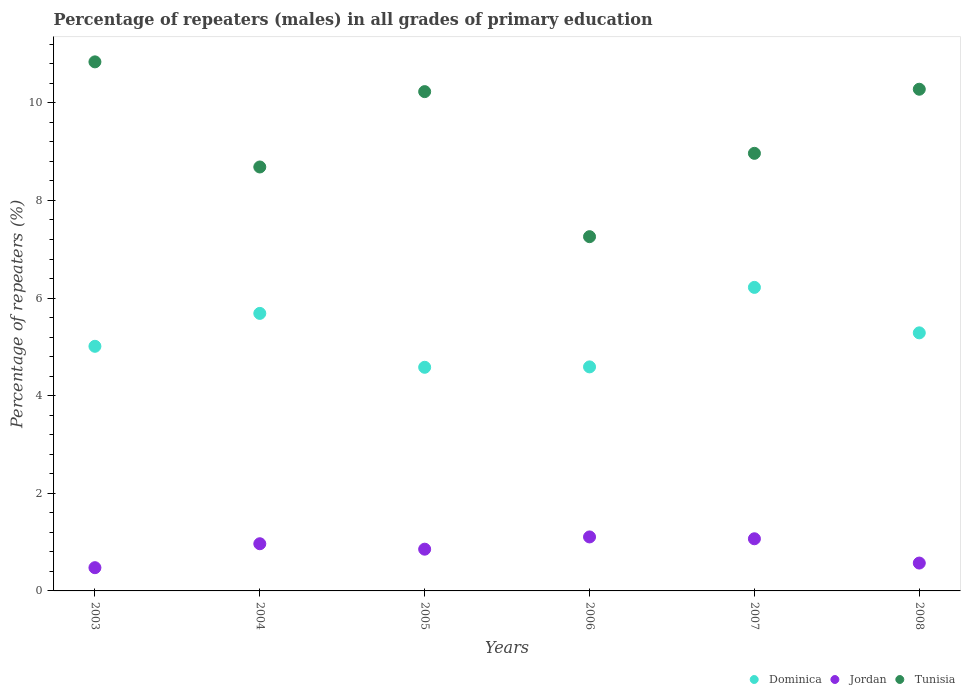What is the percentage of repeaters (males) in Tunisia in 2007?
Offer a terse response. 8.97. Across all years, what is the maximum percentage of repeaters (males) in Jordan?
Ensure brevity in your answer.  1.11. Across all years, what is the minimum percentage of repeaters (males) in Tunisia?
Offer a very short reply. 7.26. In which year was the percentage of repeaters (males) in Jordan maximum?
Your answer should be very brief. 2006. What is the total percentage of repeaters (males) in Jordan in the graph?
Provide a short and direct response. 5.04. What is the difference between the percentage of repeaters (males) in Jordan in 2004 and that in 2007?
Your response must be concise. -0.1. What is the difference between the percentage of repeaters (males) in Jordan in 2004 and the percentage of repeaters (males) in Tunisia in 2008?
Make the answer very short. -9.31. What is the average percentage of repeaters (males) in Dominica per year?
Your answer should be compact. 5.23. In the year 2006, what is the difference between the percentage of repeaters (males) in Dominica and percentage of repeaters (males) in Jordan?
Your response must be concise. 3.48. What is the ratio of the percentage of repeaters (males) in Tunisia in 2007 to that in 2008?
Keep it short and to the point. 0.87. Is the percentage of repeaters (males) in Tunisia in 2004 less than that in 2006?
Ensure brevity in your answer.  No. What is the difference between the highest and the second highest percentage of repeaters (males) in Tunisia?
Your response must be concise. 0.56. What is the difference between the highest and the lowest percentage of repeaters (males) in Dominica?
Keep it short and to the point. 1.64. Is it the case that in every year, the sum of the percentage of repeaters (males) in Tunisia and percentage of repeaters (males) in Dominica  is greater than the percentage of repeaters (males) in Jordan?
Provide a succinct answer. Yes. Is the percentage of repeaters (males) in Dominica strictly less than the percentage of repeaters (males) in Tunisia over the years?
Make the answer very short. Yes. How many years are there in the graph?
Your answer should be compact. 6. Are the values on the major ticks of Y-axis written in scientific E-notation?
Your response must be concise. No. Does the graph contain any zero values?
Keep it short and to the point. No. Where does the legend appear in the graph?
Make the answer very short. Bottom right. How many legend labels are there?
Ensure brevity in your answer.  3. What is the title of the graph?
Provide a succinct answer. Percentage of repeaters (males) in all grades of primary education. Does "Indonesia" appear as one of the legend labels in the graph?
Offer a terse response. No. What is the label or title of the X-axis?
Make the answer very short. Years. What is the label or title of the Y-axis?
Keep it short and to the point. Percentage of repeaters (%). What is the Percentage of repeaters (%) in Dominica in 2003?
Keep it short and to the point. 5.01. What is the Percentage of repeaters (%) of Jordan in 2003?
Offer a terse response. 0.48. What is the Percentage of repeaters (%) in Tunisia in 2003?
Give a very brief answer. 10.84. What is the Percentage of repeaters (%) in Dominica in 2004?
Offer a terse response. 5.69. What is the Percentage of repeaters (%) in Jordan in 2004?
Offer a terse response. 0.97. What is the Percentage of repeaters (%) of Tunisia in 2004?
Your answer should be compact. 8.69. What is the Percentage of repeaters (%) in Dominica in 2005?
Offer a terse response. 4.58. What is the Percentage of repeaters (%) in Jordan in 2005?
Give a very brief answer. 0.86. What is the Percentage of repeaters (%) of Tunisia in 2005?
Your answer should be very brief. 10.23. What is the Percentage of repeaters (%) of Dominica in 2006?
Give a very brief answer. 4.59. What is the Percentage of repeaters (%) of Jordan in 2006?
Give a very brief answer. 1.11. What is the Percentage of repeaters (%) in Tunisia in 2006?
Your answer should be very brief. 7.26. What is the Percentage of repeaters (%) of Dominica in 2007?
Provide a short and direct response. 6.22. What is the Percentage of repeaters (%) of Jordan in 2007?
Provide a succinct answer. 1.07. What is the Percentage of repeaters (%) of Tunisia in 2007?
Offer a very short reply. 8.97. What is the Percentage of repeaters (%) in Dominica in 2008?
Your answer should be compact. 5.29. What is the Percentage of repeaters (%) in Jordan in 2008?
Offer a very short reply. 0.57. What is the Percentage of repeaters (%) in Tunisia in 2008?
Make the answer very short. 10.28. Across all years, what is the maximum Percentage of repeaters (%) in Dominica?
Make the answer very short. 6.22. Across all years, what is the maximum Percentage of repeaters (%) in Jordan?
Provide a short and direct response. 1.11. Across all years, what is the maximum Percentage of repeaters (%) of Tunisia?
Your answer should be very brief. 10.84. Across all years, what is the minimum Percentage of repeaters (%) in Dominica?
Offer a terse response. 4.58. Across all years, what is the minimum Percentage of repeaters (%) of Jordan?
Provide a short and direct response. 0.48. Across all years, what is the minimum Percentage of repeaters (%) of Tunisia?
Ensure brevity in your answer.  7.26. What is the total Percentage of repeaters (%) in Dominica in the graph?
Your answer should be compact. 31.38. What is the total Percentage of repeaters (%) of Jordan in the graph?
Provide a succinct answer. 5.04. What is the total Percentage of repeaters (%) of Tunisia in the graph?
Your answer should be compact. 56.26. What is the difference between the Percentage of repeaters (%) in Dominica in 2003 and that in 2004?
Your answer should be compact. -0.67. What is the difference between the Percentage of repeaters (%) in Jordan in 2003 and that in 2004?
Ensure brevity in your answer.  -0.49. What is the difference between the Percentage of repeaters (%) in Tunisia in 2003 and that in 2004?
Offer a very short reply. 2.15. What is the difference between the Percentage of repeaters (%) in Dominica in 2003 and that in 2005?
Provide a succinct answer. 0.43. What is the difference between the Percentage of repeaters (%) in Jordan in 2003 and that in 2005?
Make the answer very short. -0.38. What is the difference between the Percentage of repeaters (%) of Tunisia in 2003 and that in 2005?
Keep it short and to the point. 0.61. What is the difference between the Percentage of repeaters (%) in Dominica in 2003 and that in 2006?
Provide a short and direct response. 0.42. What is the difference between the Percentage of repeaters (%) of Jordan in 2003 and that in 2006?
Your answer should be very brief. -0.63. What is the difference between the Percentage of repeaters (%) of Tunisia in 2003 and that in 2006?
Offer a very short reply. 3.58. What is the difference between the Percentage of repeaters (%) of Dominica in 2003 and that in 2007?
Offer a terse response. -1.21. What is the difference between the Percentage of repeaters (%) of Jordan in 2003 and that in 2007?
Offer a very short reply. -0.59. What is the difference between the Percentage of repeaters (%) in Tunisia in 2003 and that in 2007?
Keep it short and to the point. 1.87. What is the difference between the Percentage of repeaters (%) in Dominica in 2003 and that in 2008?
Provide a succinct answer. -0.28. What is the difference between the Percentage of repeaters (%) in Jordan in 2003 and that in 2008?
Your response must be concise. -0.09. What is the difference between the Percentage of repeaters (%) of Tunisia in 2003 and that in 2008?
Offer a very short reply. 0.56. What is the difference between the Percentage of repeaters (%) of Dominica in 2004 and that in 2005?
Keep it short and to the point. 1.1. What is the difference between the Percentage of repeaters (%) in Jordan in 2004 and that in 2005?
Your response must be concise. 0.11. What is the difference between the Percentage of repeaters (%) in Tunisia in 2004 and that in 2005?
Give a very brief answer. -1.54. What is the difference between the Percentage of repeaters (%) of Dominica in 2004 and that in 2006?
Ensure brevity in your answer.  1.1. What is the difference between the Percentage of repeaters (%) in Jordan in 2004 and that in 2006?
Ensure brevity in your answer.  -0.14. What is the difference between the Percentage of repeaters (%) in Tunisia in 2004 and that in 2006?
Give a very brief answer. 1.43. What is the difference between the Percentage of repeaters (%) of Dominica in 2004 and that in 2007?
Your answer should be very brief. -0.53. What is the difference between the Percentage of repeaters (%) of Jordan in 2004 and that in 2007?
Your answer should be compact. -0.1. What is the difference between the Percentage of repeaters (%) in Tunisia in 2004 and that in 2007?
Give a very brief answer. -0.28. What is the difference between the Percentage of repeaters (%) in Dominica in 2004 and that in 2008?
Keep it short and to the point. 0.4. What is the difference between the Percentage of repeaters (%) of Jordan in 2004 and that in 2008?
Provide a short and direct response. 0.4. What is the difference between the Percentage of repeaters (%) in Tunisia in 2004 and that in 2008?
Provide a succinct answer. -1.59. What is the difference between the Percentage of repeaters (%) in Dominica in 2005 and that in 2006?
Offer a very short reply. -0.01. What is the difference between the Percentage of repeaters (%) of Jordan in 2005 and that in 2006?
Keep it short and to the point. -0.25. What is the difference between the Percentage of repeaters (%) in Tunisia in 2005 and that in 2006?
Your response must be concise. 2.97. What is the difference between the Percentage of repeaters (%) of Dominica in 2005 and that in 2007?
Make the answer very short. -1.64. What is the difference between the Percentage of repeaters (%) of Jordan in 2005 and that in 2007?
Your response must be concise. -0.21. What is the difference between the Percentage of repeaters (%) of Tunisia in 2005 and that in 2007?
Keep it short and to the point. 1.26. What is the difference between the Percentage of repeaters (%) in Dominica in 2005 and that in 2008?
Keep it short and to the point. -0.71. What is the difference between the Percentage of repeaters (%) of Jordan in 2005 and that in 2008?
Make the answer very short. 0.28. What is the difference between the Percentage of repeaters (%) in Tunisia in 2005 and that in 2008?
Give a very brief answer. -0.05. What is the difference between the Percentage of repeaters (%) of Dominica in 2006 and that in 2007?
Offer a terse response. -1.63. What is the difference between the Percentage of repeaters (%) of Jordan in 2006 and that in 2007?
Your answer should be very brief. 0.04. What is the difference between the Percentage of repeaters (%) in Tunisia in 2006 and that in 2007?
Keep it short and to the point. -1.71. What is the difference between the Percentage of repeaters (%) of Dominica in 2006 and that in 2008?
Your answer should be very brief. -0.7. What is the difference between the Percentage of repeaters (%) of Jordan in 2006 and that in 2008?
Keep it short and to the point. 0.54. What is the difference between the Percentage of repeaters (%) in Tunisia in 2006 and that in 2008?
Your response must be concise. -3.02. What is the difference between the Percentage of repeaters (%) of Dominica in 2007 and that in 2008?
Make the answer very short. 0.93. What is the difference between the Percentage of repeaters (%) of Jordan in 2007 and that in 2008?
Provide a short and direct response. 0.5. What is the difference between the Percentage of repeaters (%) in Tunisia in 2007 and that in 2008?
Offer a very short reply. -1.31. What is the difference between the Percentage of repeaters (%) in Dominica in 2003 and the Percentage of repeaters (%) in Jordan in 2004?
Offer a very short reply. 4.05. What is the difference between the Percentage of repeaters (%) of Dominica in 2003 and the Percentage of repeaters (%) of Tunisia in 2004?
Provide a succinct answer. -3.67. What is the difference between the Percentage of repeaters (%) of Jordan in 2003 and the Percentage of repeaters (%) of Tunisia in 2004?
Offer a very short reply. -8.21. What is the difference between the Percentage of repeaters (%) of Dominica in 2003 and the Percentage of repeaters (%) of Jordan in 2005?
Provide a succinct answer. 4.16. What is the difference between the Percentage of repeaters (%) in Dominica in 2003 and the Percentage of repeaters (%) in Tunisia in 2005?
Your answer should be very brief. -5.22. What is the difference between the Percentage of repeaters (%) of Jordan in 2003 and the Percentage of repeaters (%) of Tunisia in 2005?
Ensure brevity in your answer.  -9.75. What is the difference between the Percentage of repeaters (%) in Dominica in 2003 and the Percentage of repeaters (%) in Jordan in 2006?
Your response must be concise. 3.91. What is the difference between the Percentage of repeaters (%) in Dominica in 2003 and the Percentage of repeaters (%) in Tunisia in 2006?
Ensure brevity in your answer.  -2.25. What is the difference between the Percentage of repeaters (%) in Jordan in 2003 and the Percentage of repeaters (%) in Tunisia in 2006?
Make the answer very short. -6.78. What is the difference between the Percentage of repeaters (%) of Dominica in 2003 and the Percentage of repeaters (%) of Jordan in 2007?
Keep it short and to the point. 3.94. What is the difference between the Percentage of repeaters (%) of Dominica in 2003 and the Percentage of repeaters (%) of Tunisia in 2007?
Offer a very short reply. -3.95. What is the difference between the Percentage of repeaters (%) of Jordan in 2003 and the Percentage of repeaters (%) of Tunisia in 2007?
Ensure brevity in your answer.  -8.49. What is the difference between the Percentage of repeaters (%) of Dominica in 2003 and the Percentage of repeaters (%) of Jordan in 2008?
Provide a succinct answer. 4.44. What is the difference between the Percentage of repeaters (%) in Dominica in 2003 and the Percentage of repeaters (%) in Tunisia in 2008?
Give a very brief answer. -5.27. What is the difference between the Percentage of repeaters (%) of Jordan in 2003 and the Percentage of repeaters (%) of Tunisia in 2008?
Give a very brief answer. -9.8. What is the difference between the Percentage of repeaters (%) in Dominica in 2004 and the Percentage of repeaters (%) in Jordan in 2005?
Offer a terse response. 4.83. What is the difference between the Percentage of repeaters (%) in Dominica in 2004 and the Percentage of repeaters (%) in Tunisia in 2005?
Keep it short and to the point. -4.54. What is the difference between the Percentage of repeaters (%) in Jordan in 2004 and the Percentage of repeaters (%) in Tunisia in 2005?
Provide a succinct answer. -9.26. What is the difference between the Percentage of repeaters (%) of Dominica in 2004 and the Percentage of repeaters (%) of Jordan in 2006?
Provide a succinct answer. 4.58. What is the difference between the Percentage of repeaters (%) in Dominica in 2004 and the Percentage of repeaters (%) in Tunisia in 2006?
Make the answer very short. -1.57. What is the difference between the Percentage of repeaters (%) of Jordan in 2004 and the Percentage of repeaters (%) of Tunisia in 2006?
Offer a terse response. -6.29. What is the difference between the Percentage of repeaters (%) of Dominica in 2004 and the Percentage of repeaters (%) of Jordan in 2007?
Offer a very short reply. 4.62. What is the difference between the Percentage of repeaters (%) of Dominica in 2004 and the Percentage of repeaters (%) of Tunisia in 2007?
Offer a very short reply. -3.28. What is the difference between the Percentage of repeaters (%) of Jordan in 2004 and the Percentage of repeaters (%) of Tunisia in 2007?
Give a very brief answer. -8. What is the difference between the Percentage of repeaters (%) of Dominica in 2004 and the Percentage of repeaters (%) of Jordan in 2008?
Give a very brief answer. 5.12. What is the difference between the Percentage of repeaters (%) in Dominica in 2004 and the Percentage of repeaters (%) in Tunisia in 2008?
Your answer should be compact. -4.59. What is the difference between the Percentage of repeaters (%) in Jordan in 2004 and the Percentage of repeaters (%) in Tunisia in 2008?
Make the answer very short. -9.31. What is the difference between the Percentage of repeaters (%) in Dominica in 2005 and the Percentage of repeaters (%) in Jordan in 2006?
Ensure brevity in your answer.  3.48. What is the difference between the Percentage of repeaters (%) in Dominica in 2005 and the Percentage of repeaters (%) in Tunisia in 2006?
Your response must be concise. -2.68. What is the difference between the Percentage of repeaters (%) in Jordan in 2005 and the Percentage of repeaters (%) in Tunisia in 2006?
Keep it short and to the point. -6.4. What is the difference between the Percentage of repeaters (%) in Dominica in 2005 and the Percentage of repeaters (%) in Jordan in 2007?
Provide a short and direct response. 3.51. What is the difference between the Percentage of repeaters (%) of Dominica in 2005 and the Percentage of repeaters (%) of Tunisia in 2007?
Offer a very short reply. -4.38. What is the difference between the Percentage of repeaters (%) of Jordan in 2005 and the Percentage of repeaters (%) of Tunisia in 2007?
Ensure brevity in your answer.  -8.11. What is the difference between the Percentage of repeaters (%) of Dominica in 2005 and the Percentage of repeaters (%) of Jordan in 2008?
Provide a short and direct response. 4.01. What is the difference between the Percentage of repeaters (%) of Dominica in 2005 and the Percentage of repeaters (%) of Tunisia in 2008?
Your answer should be compact. -5.7. What is the difference between the Percentage of repeaters (%) in Jordan in 2005 and the Percentage of repeaters (%) in Tunisia in 2008?
Offer a very short reply. -9.42. What is the difference between the Percentage of repeaters (%) in Dominica in 2006 and the Percentage of repeaters (%) in Jordan in 2007?
Provide a succinct answer. 3.52. What is the difference between the Percentage of repeaters (%) of Dominica in 2006 and the Percentage of repeaters (%) of Tunisia in 2007?
Your response must be concise. -4.38. What is the difference between the Percentage of repeaters (%) in Jordan in 2006 and the Percentage of repeaters (%) in Tunisia in 2007?
Provide a succinct answer. -7.86. What is the difference between the Percentage of repeaters (%) in Dominica in 2006 and the Percentage of repeaters (%) in Jordan in 2008?
Offer a terse response. 4.02. What is the difference between the Percentage of repeaters (%) in Dominica in 2006 and the Percentage of repeaters (%) in Tunisia in 2008?
Offer a very short reply. -5.69. What is the difference between the Percentage of repeaters (%) of Jordan in 2006 and the Percentage of repeaters (%) of Tunisia in 2008?
Provide a succinct answer. -9.17. What is the difference between the Percentage of repeaters (%) in Dominica in 2007 and the Percentage of repeaters (%) in Jordan in 2008?
Offer a very short reply. 5.65. What is the difference between the Percentage of repeaters (%) of Dominica in 2007 and the Percentage of repeaters (%) of Tunisia in 2008?
Ensure brevity in your answer.  -4.06. What is the difference between the Percentage of repeaters (%) in Jordan in 2007 and the Percentage of repeaters (%) in Tunisia in 2008?
Your answer should be very brief. -9.21. What is the average Percentage of repeaters (%) in Dominica per year?
Your answer should be compact. 5.23. What is the average Percentage of repeaters (%) of Jordan per year?
Give a very brief answer. 0.84. What is the average Percentage of repeaters (%) in Tunisia per year?
Your answer should be very brief. 9.38. In the year 2003, what is the difference between the Percentage of repeaters (%) of Dominica and Percentage of repeaters (%) of Jordan?
Your response must be concise. 4.54. In the year 2003, what is the difference between the Percentage of repeaters (%) in Dominica and Percentage of repeaters (%) in Tunisia?
Your answer should be compact. -5.83. In the year 2003, what is the difference between the Percentage of repeaters (%) of Jordan and Percentage of repeaters (%) of Tunisia?
Ensure brevity in your answer.  -10.36. In the year 2004, what is the difference between the Percentage of repeaters (%) of Dominica and Percentage of repeaters (%) of Jordan?
Your answer should be very brief. 4.72. In the year 2004, what is the difference between the Percentage of repeaters (%) of Dominica and Percentage of repeaters (%) of Tunisia?
Your response must be concise. -3. In the year 2004, what is the difference between the Percentage of repeaters (%) of Jordan and Percentage of repeaters (%) of Tunisia?
Give a very brief answer. -7.72. In the year 2005, what is the difference between the Percentage of repeaters (%) of Dominica and Percentage of repeaters (%) of Jordan?
Your response must be concise. 3.73. In the year 2005, what is the difference between the Percentage of repeaters (%) in Dominica and Percentage of repeaters (%) in Tunisia?
Your answer should be compact. -5.65. In the year 2005, what is the difference between the Percentage of repeaters (%) of Jordan and Percentage of repeaters (%) of Tunisia?
Offer a very short reply. -9.37. In the year 2006, what is the difference between the Percentage of repeaters (%) of Dominica and Percentage of repeaters (%) of Jordan?
Ensure brevity in your answer.  3.48. In the year 2006, what is the difference between the Percentage of repeaters (%) of Dominica and Percentage of repeaters (%) of Tunisia?
Your answer should be very brief. -2.67. In the year 2006, what is the difference between the Percentage of repeaters (%) of Jordan and Percentage of repeaters (%) of Tunisia?
Keep it short and to the point. -6.15. In the year 2007, what is the difference between the Percentage of repeaters (%) of Dominica and Percentage of repeaters (%) of Jordan?
Your answer should be compact. 5.15. In the year 2007, what is the difference between the Percentage of repeaters (%) in Dominica and Percentage of repeaters (%) in Tunisia?
Provide a succinct answer. -2.75. In the year 2007, what is the difference between the Percentage of repeaters (%) of Jordan and Percentage of repeaters (%) of Tunisia?
Your answer should be compact. -7.9. In the year 2008, what is the difference between the Percentage of repeaters (%) in Dominica and Percentage of repeaters (%) in Jordan?
Provide a short and direct response. 4.72. In the year 2008, what is the difference between the Percentage of repeaters (%) in Dominica and Percentage of repeaters (%) in Tunisia?
Your response must be concise. -4.99. In the year 2008, what is the difference between the Percentage of repeaters (%) of Jordan and Percentage of repeaters (%) of Tunisia?
Your answer should be compact. -9.71. What is the ratio of the Percentage of repeaters (%) of Dominica in 2003 to that in 2004?
Ensure brevity in your answer.  0.88. What is the ratio of the Percentage of repeaters (%) of Jordan in 2003 to that in 2004?
Offer a terse response. 0.49. What is the ratio of the Percentage of repeaters (%) of Tunisia in 2003 to that in 2004?
Offer a very short reply. 1.25. What is the ratio of the Percentage of repeaters (%) of Dominica in 2003 to that in 2005?
Ensure brevity in your answer.  1.09. What is the ratio of the Percentage of repeaters (%) in Jordan in 2003 to that in 2005?
Offer a very short reply. 0.56. What is the ratio of the Percentage of repeaters (%) in Tunisia in 2003 to that in 2005?
Offer a very short reply. 1.06. What is the ratio of the Percentage of repeaters (%) in Dominica in 2003 to that in 2006?
Provide a succinct answer. 1.09. What is the ratio of the Percentage of repeaters (%) in Jordan in 2003 to that in 2006?
Provide a succinct answer. 0.43. What is the ratio of the Percentage of repeaters (%) in Tunisia in 2003 to that in 2006?
Keep it short and to the point. 1.49. What is the ratio of the Percentage of repeaters (%) of Dominica in 2003 to that in 2007?
Provide a succinct answer. 0.81. What is the ratio of the Percentage of repeaters (%) in Jordan in 2003 to that in 2007?
Your answer should be compact. 0.45. What is the ratio of the Percentage of repeaters (%) of Tunisia in 2003 to that in 2007?
Provide a succinct answer. 1.21. What is the ratio of the Percentage of repeaters (%) of Dominica in 2003 to that in 2008?
Offer a terse response. 0.95. What is the ratio of the Percentage of repeaters (%) in Jordan in 2003 to that in 2008?
Your response must be concise. 0.83. What is the ratio of the Percentage of repeaters (%) in Tunisia in 2003 to that in 2008?
Offer a terse response. 1.05. What is the ratio of the Percentage of repeaters (%) in Dominica in 2004 to that in 2005?
Give a very brief answer. 1.24. What is the ratio of the Percentage of repeaters (%) in Jordan in 2004 to that in 2005?
Offer a terse response. 1.13. What is the ratio of the Percentage of repeaters (%) in Tunisia in 2004 to that in 2005?
Provide a succinct answer. 0.85. What is the ratio of the Percentage of repeaters (%) of Dominica in 2004 to that in 2006?
Give a very brief answer. 1.24. What is the ratio of the Percentage of repeaters (%) in Jordan in 2004 to that in 2006?
Provide a succinct answer. 0.87. What is the ratio of the Percentage of repeaters (%) of Tunisia in 2004 to that in 2006?
Provide a succinct answer. 1.2. What is the ratio of the Percentage of repeaters (%) of Dominica in 2004 to that in 2007?
Provide a succinct answer. 0.91. What is the ratio of the Percentage of repeaters (%) in Jordan in 2004 to that in 2007?
Give a very brief answer. 0.9. What is the ratio of the Percentage of repeaters (%) in Tunisia in 2004 to that in 2007?
Keep it short and to the point. 0.97. What is the ratio of the Percentage of repeaters (%) of Dominica in 2004 to that in 2008?
Make the answer very short. 1.08. What is the ratio of the Percentage of repeaters (%) in Jordan in 2004 to that in 2008?
Your answer should be compact. 1.69. What is the ratio of the Percentage of repeaters (%) of Tunisia in 2004 to that in 2008?
Keep it short and to the point. 0.84. What is the ratio of the Percentage of repeaters (%) of Dominica in 2005 to that in 2006?
Your response must be concise. 1. What is the ratio of the Percentage of repeaters (%) in Jordan in 2005 to that in 2006?
Ensure brevity in your answer.  0.77. What is the ratio of the Percentage of repeaters (%) of Tunisia in 2005 to that in 2006?
Provide a succinct answer. 1.41. What is the ratio of the Percentage of repeaters (%) of Dominica in 2005 to that in 2007?
Offer a very short reply. 0.74. What is the ratio of the Percentage of repeaters (%) of Jordan in 2005 to that in 2007?
Your answer should be compact. 0.8. What is the ratio of the Percentage of repeaters (%) of Tunisia in 2005 to that in 2007?
Your response must be concise. 1.14. What is the ratio of the Percentage of repeaters (%) of Dominica in 2005 to that in 2008?
Offer a terse response. 0.87. What is the ratio of the Percentage of repeaters (%) in Jordan in 2005 to that in 2008?
Offer a terse response. 1.5. What is the ratio of the Percentage of repeaters (%) in Dominica in 2006 to that in 2007?
Your answer should be compact. 0.74. What is the ratio of the Percentage of repeaters (%) of Jordan in 2006 to that in 2007?
Your answer should be very brief. 1.04. What is the ratio of the Percentage of repeaters (%) in Tunisia in 2006 to that in 2007?
Your answer should be compact. 0.81. What is the ratio of the Percentage of repeaters (%) in Dominica in 2006 to that in 2008?
Your response must be concise. 0.87. What is the ratio of the Percentage of repeaters (%) in Jordan in 2006 to that in 2008?
Offer a terse response. 1.94. What is the ratio of the Percentage of repeaters (%) in Tunisia in 2006 to that in 2008?
Ensure brevity in your answer.  0.71. What is the ratio of the Percentage of repeaters (%) of Dominica in 2007 to that in 2008?
Your response must be concise. 1.18. What is the ratio of the Percentage of repeaters (%) in Jordan in 2007 to that in 2008?
Your answer should be very brief. 1.87. What is the ratio of the Percentage of repeaters (%) in Tunisia in 2007 to that in 2008?
Your answer should be very brief. 0.87. What is the difference between the highest and the second highest Percentage of repeaters (%) in Dominica?
Make the answer very short. 0.53. What is the difference between the highest and the second highest Percentage of repeaters (%) in Jordan?
Make the answer very short. 0.04. What is the difference between the highest and the second highest Percentage of repeaters (%) in Tunisia?
Ensure brevity in your answer.  0.56. What is the difference between the highest and the lowest Percentage of repeaters (%) of Dominica?
Ensure brevity in your answer.  1.64. What is the difference between the highest and the lowest Percentage of repeaters (%) in Jordan?
Your response must be concise. 0.63. What is the difference between the highest and the lowest Percentage of repeaters (%) in Tunisia?
Keep it short and to the point. 3.58. 